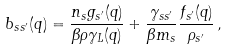<formula> <loc_0><loc_0><loc_500><loc_500>b _ { s s ^ { \prime } } ( q ) = \frac { n _ { s } g _ { s ^ { \prime } } ( q ) } { \beta \rho \gamma _ { L } ( q ) } + \frac { \gamma _ { s s ^ { \prime } } } { \beta m _ { s } } \frac { f _ { s ^ { \prime } } ( q ) } { \rho _ { s ^ { \prime } } } \, ,</formula> 